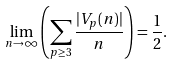Convert formula to latex. <formula><loc_0><loc_0><loc_500><loc_500>\lim _ { n \rightarrow \infty } \left ( \sum _ { p \geq 3 } \frac { | V _ { p } ( n ) | } { n } \right ) = \frac { 1 } { 2 } .</formula> 